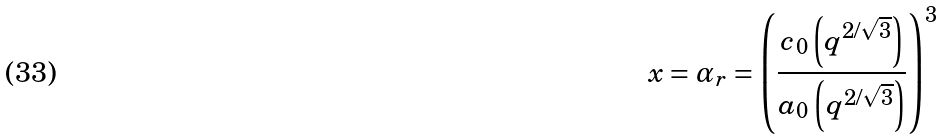Convert formula to latex. <formula><loc_0><loc_0><loc_500><loc_500>x = \alpha _ { r } = \left ( \frac { c _ { 0 } \left ( q ^ { 2 / \sqrt { 3 } } \right ) } { a _ { 0 } \left ( q ^ { 2 / \sqrt { 3 } } \right ) } \right ) ^ { 3 }</formula> 